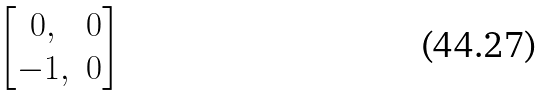<formula> <loc_0><loc_0><loc_500><loc_500>\begin{bmatrix} 0 , & 0 \\ - 1 , & 0 \end{bmatrix}</formula> 